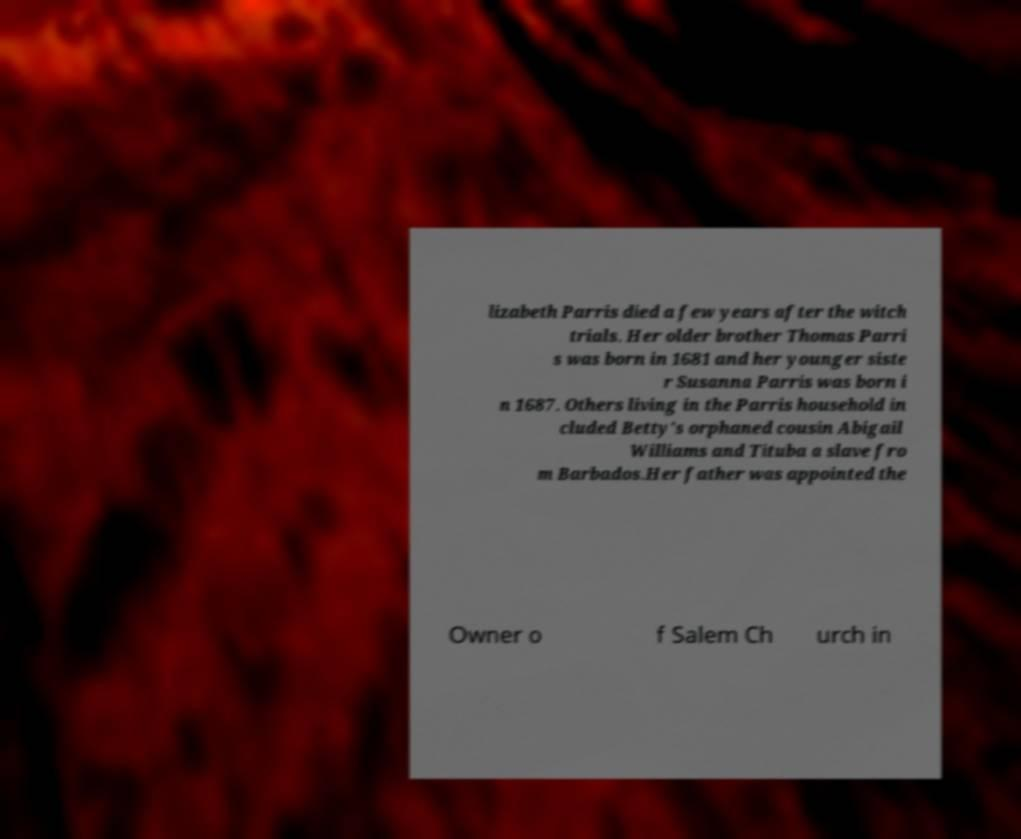For documentation purposes, I need the text within this image transcribed. Could you provide that? lizabeth Parris died a few years after the witch trials. Her older brother Thomas Parri s was born in 1681 and her younger siste r Susanna Parris was born i n 1687. Others living in the Parris household in cluded Betty's orphaned cousin Abigail Williams and Tituba a slave fro m Barbados.Her father was appointed the Owner o f Salem Ch urch in 